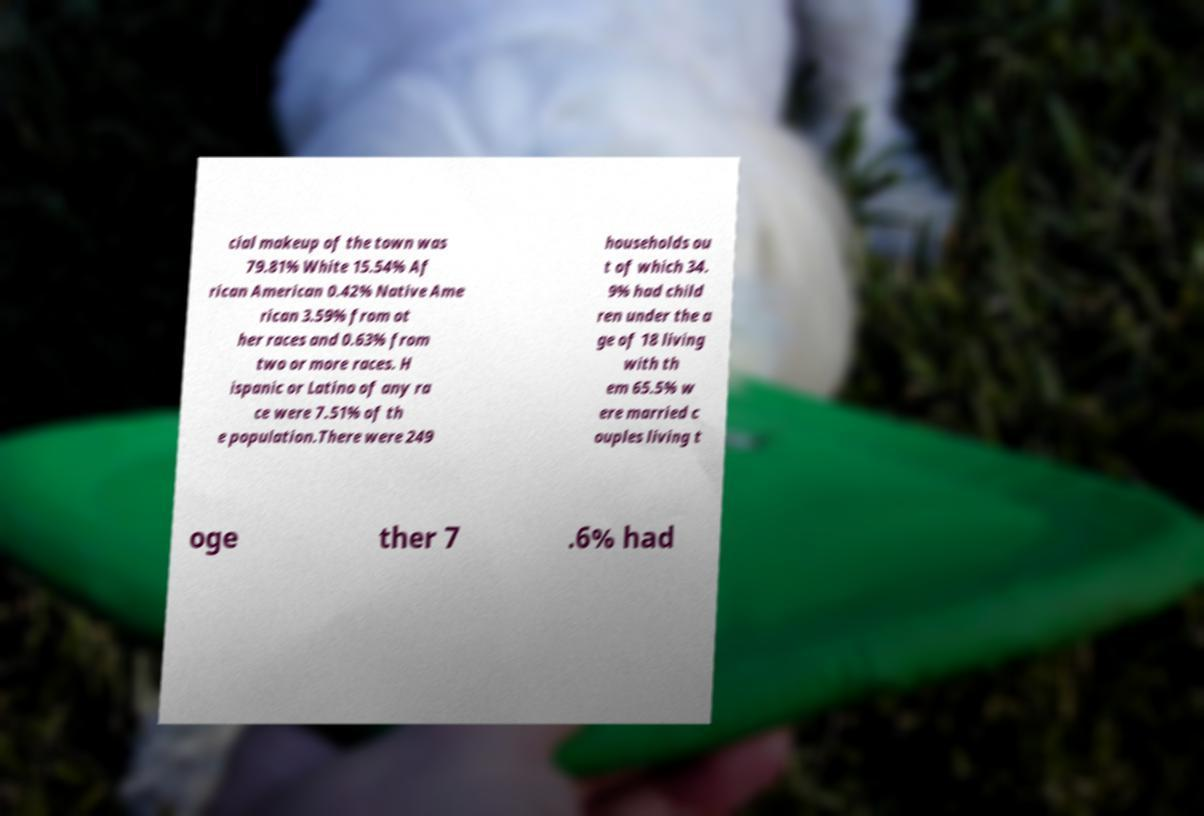Could you assist in decoding the text presented in this image and type it out clearly? cial makeup of the town was 79.81% White 15.54% Af rican American 0.42% Native Ame rican 3.59% from ot her races and 0.63% from two or more races. H ispanic or Latino of any ra ce were 7.51% of th e population.There were 249 households ou t of which 34. 9% had child ren under the a ge of 18 living with th em 65.5% w ere married c ouples living t oge ther 7 .6% had 